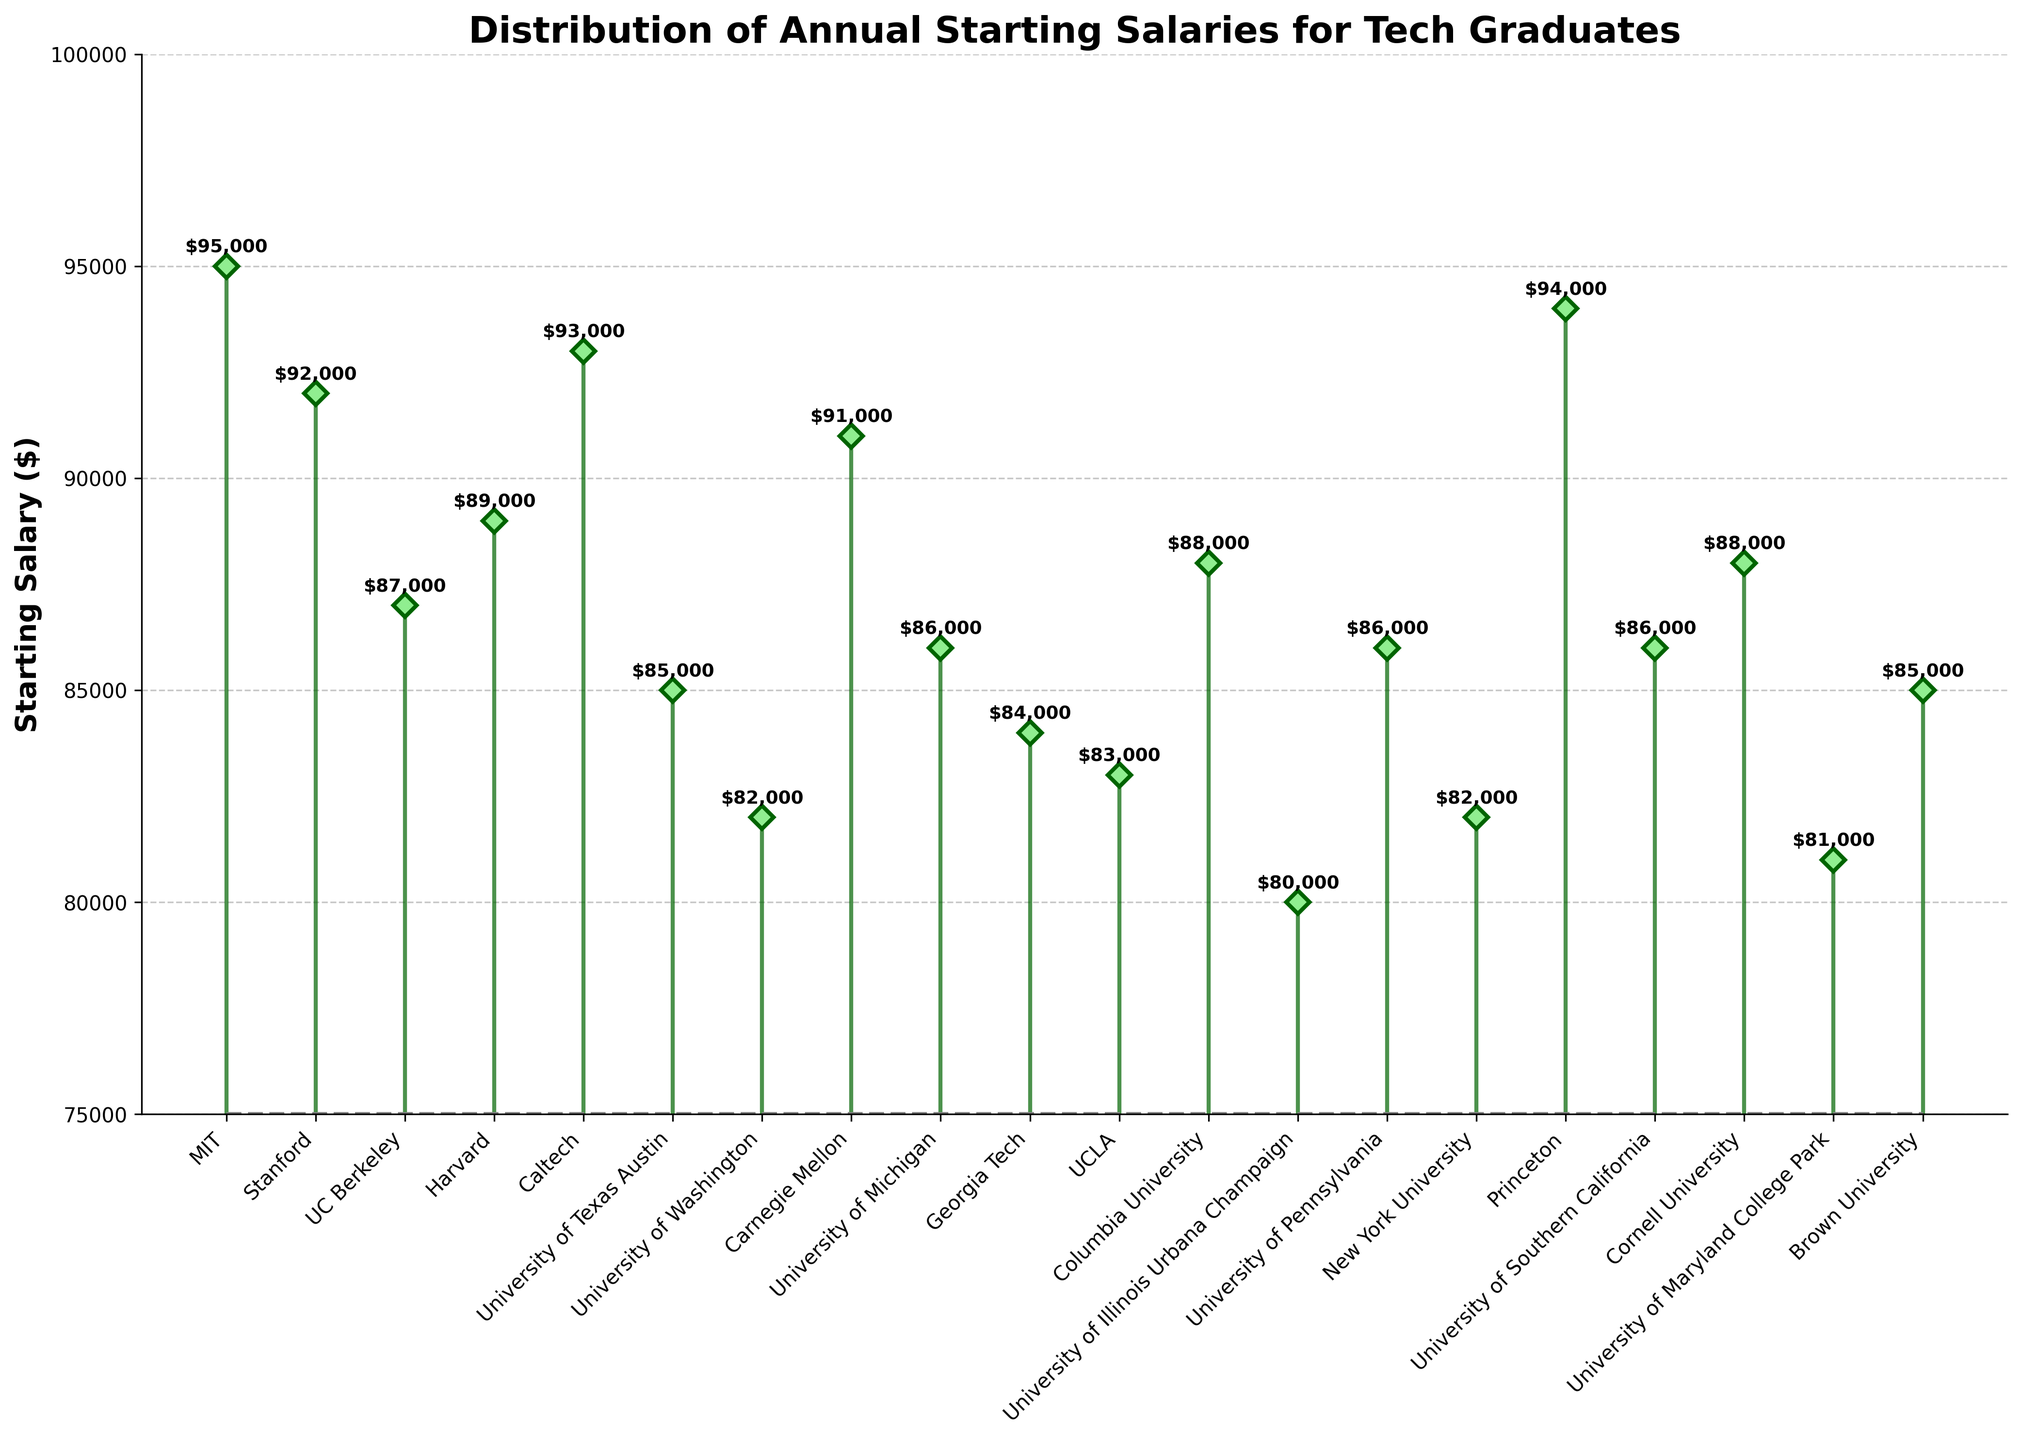What's the highest starting salary among the universities? First, identify the highest data point from the markers on the plot. The highest marker corresponds to a university with a salary of $95,000. Detail checking shows MIT has this value.
Answer: $95,000 Which university has the lowest starting salary? Identify the lowest marker on the plot. The lowest marker corresponds to a salary of $80,000, which is associated with the University of Illinois Urbana-Champaign.
Answer: University of Illinois Urbana-Champaign What's the average starting salary of the universities listed? Sum all the starting salaries and divide by the total number of universities. The data provided has 20 universities with respective salaries. The sum is $1,723,000, and the average is $1,723,000 / 20 = $86,150.
Answer: $86,150 How much higher is the starting salary of MIT compared to the University of Washington? MIT's salary is $95,000, and the University of Washington's is $82,000. The difference is $95,000 - $82,000 = $13,000.
Answer: $13,000 List two universities with starting salaries greater than $90,000. Look for markers above the $90,000 line. MIT, Stanford, Caltech, and Princeton fit this criterion.
Answer: MIT, Princeton Which two universities have starting salaries around the median value? To find the median, sort the salaries and locate the middle value(s). For 20 data points, the median is the average of the 10th and 11th salaries when sorted. The sorted salaries give $86000 and $86000 which are University of Michigan and University of Pennsylvania.
Answer: University of Michigan, University of Pennsylvania What's the title of the plot? The title is typically located at the top of the plot. Here, it reads "Distribution of Annual Starting Salaries for Tech Graduates".
Answer: Distribution of Annual Starting Salaries for Tech Graduates How many universities have starting salaries between $80,000 and $85,000? Count the markers that fall within this range. Universities with salaries of $81,000 (University of Maryland College Park), $82,000 (University of Washington and NYU), $83,000 (UCLA), and $84,000 (Georgia Tech) fit this criterion.
Answer: 5 Which universities have starting salaries exactly equal to $86,000? Identify markers at this specific point. Universities of Michigan, Pennsylvania, and Southern California all have $86,000 starting salaries.
Answer: University of Michigan, University of Pennsylvania, University of Southern California What is the range of the starting salaries? The range is calculated by subtracting the lowest starting salary from the highest. The highest is $95,000 and the lowest is $80,000, so the range is $95,000 - $80,000 = $15,000.
Answer: $15,000 